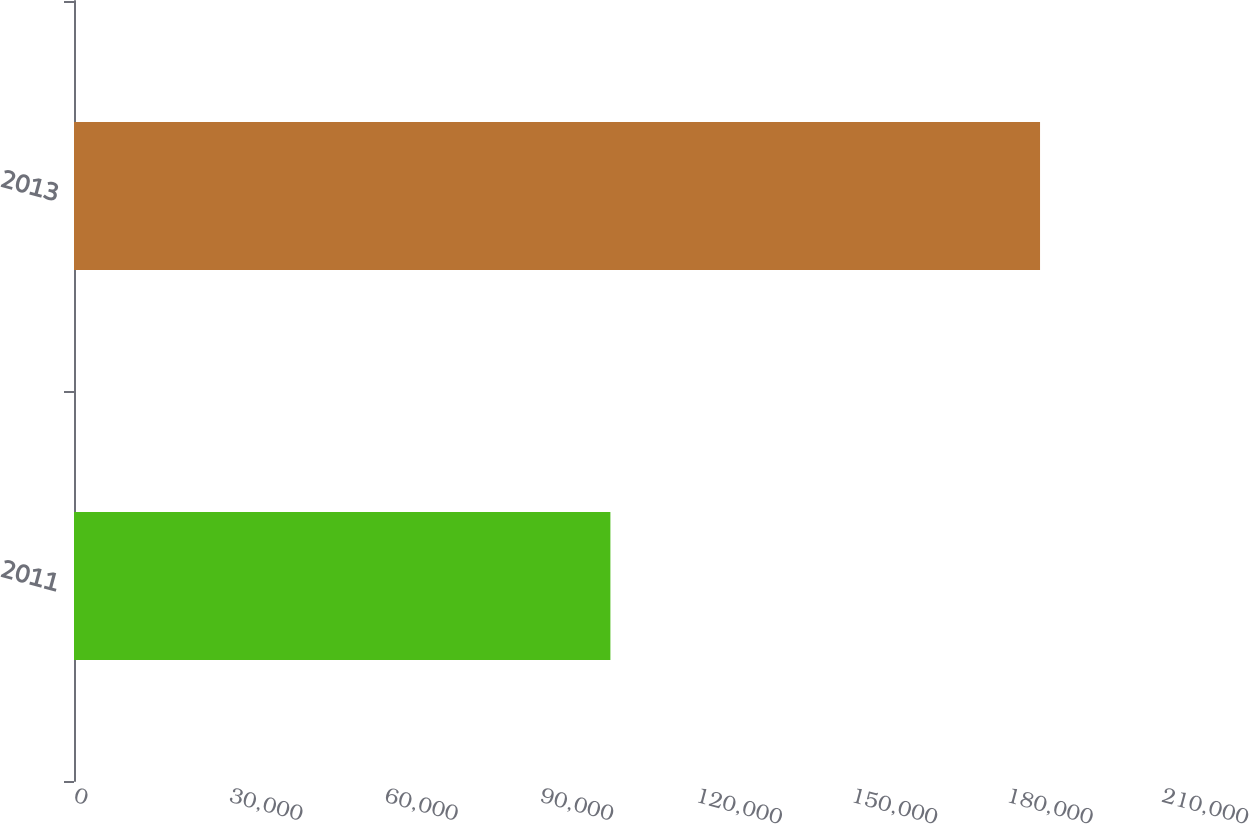Convert chart to OTSL. <chart><loc_0><loc_0><loc_500><loc_500><bar_chart><fcel>2011<fcel>2013<nl><fcel>103532<fcel>186460<nl></chart> 